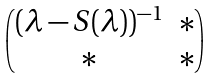Convert formula to latex. <formula><loc_0><loc_0><loc_500><loc_500>\begin{pmatrix} ( \lambda - S ( \lambda ) ) ^ { - 1 } & * \\ * & * \end{pmatrix}</formula> 